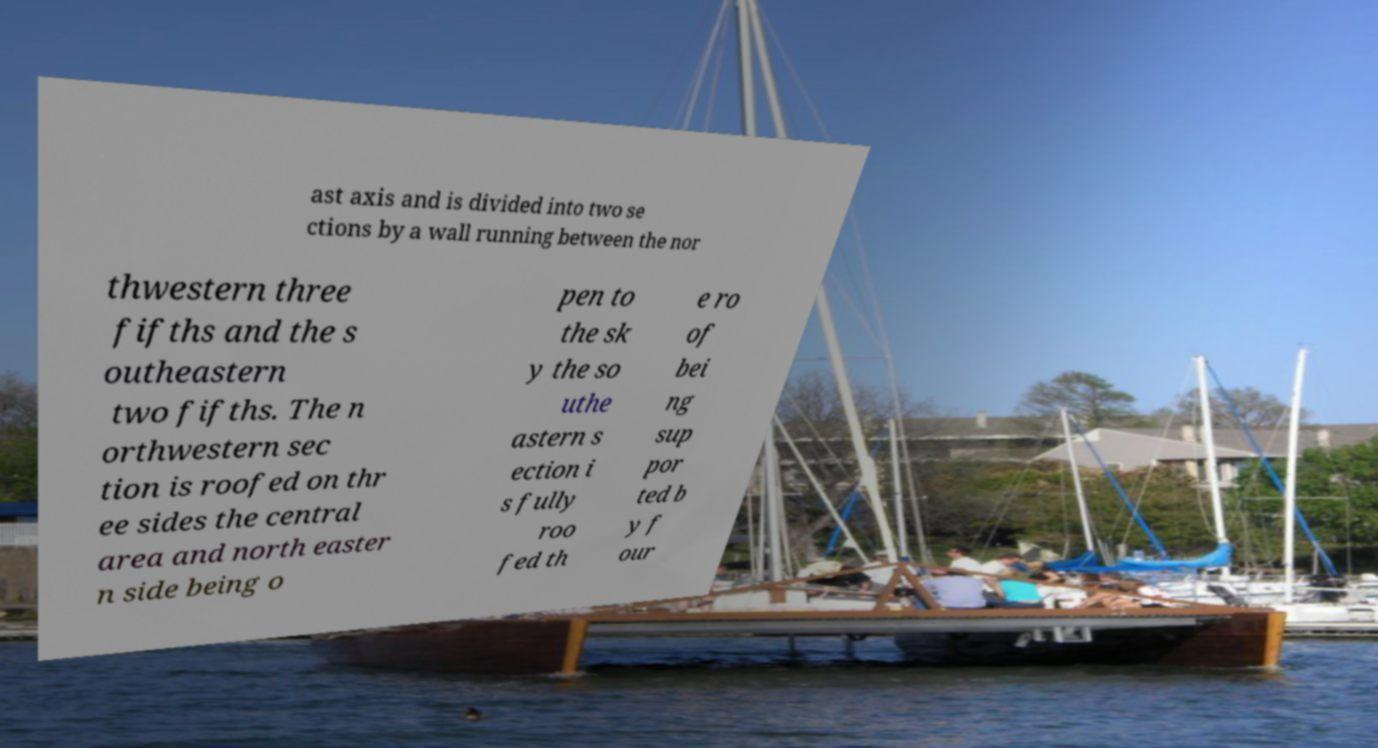Please read and relay the text visible in this image. What does it say? ast axis and is divided into two se ctions by a wall running between the nor thwestern three fifths and the s outheastern two fifths. The n orthwestern sec tion is roofed on thr ee sides the central area and north easter n side being o pen to the sk y the so uthe astern s ection i s fully roo fed th e ro of bei ng sup por ted b y f our 